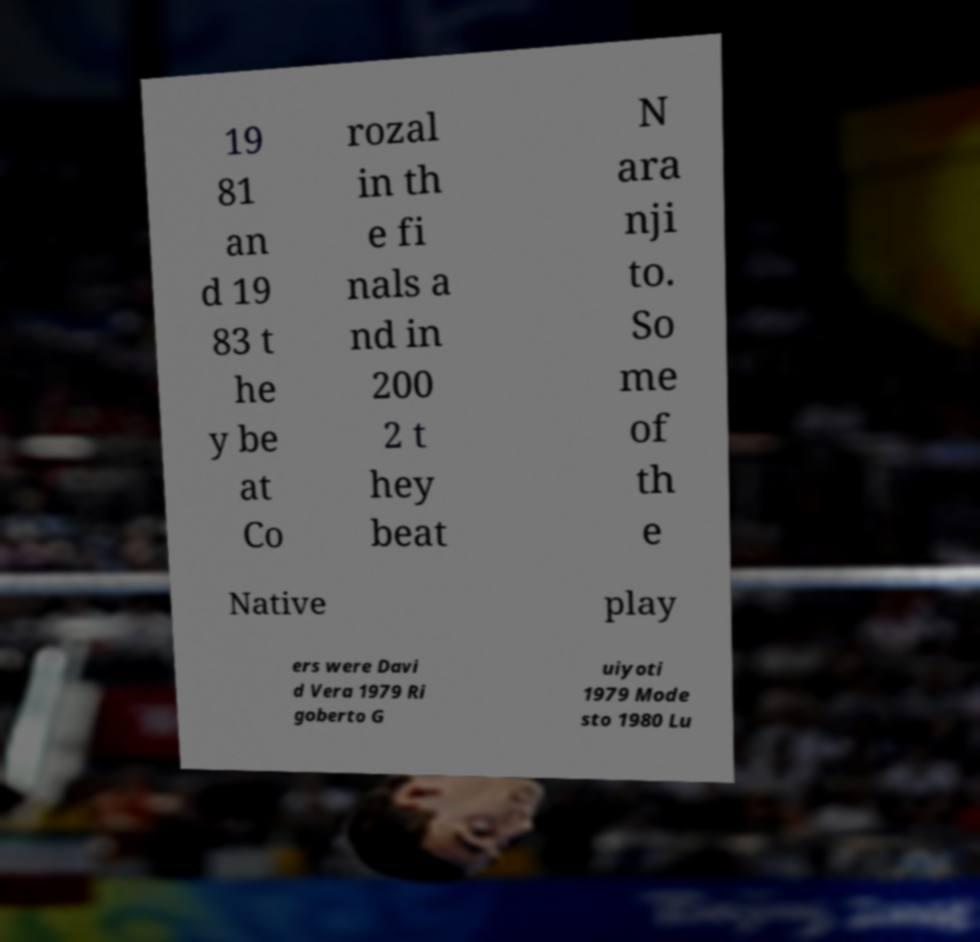There's text embedded in this image that I need extracted. Can you transcribe it verbatim? 19 81 an d 19 83 t he y be at Co rozal in th e fi nals a nd in 200 2 t hey beat N ara nji to. So me of th e Native play ers were Davi d Vera 1979 Ri goberto G uiyoti 1979 Mode sto 1980 Lu 